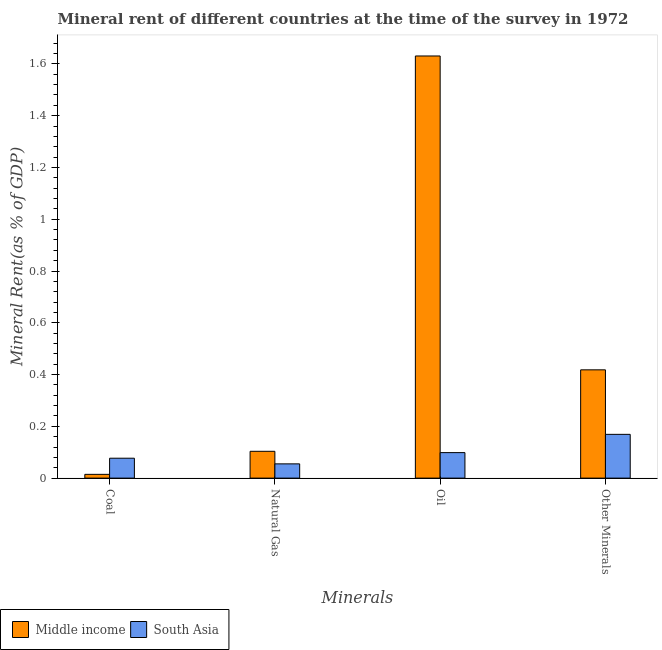How many groups of bars are there?
Your answer should be compact. 4. Are the number of bars on each tick of the X-axis equal?
Your answer should be very brief. Yes. What is the label of the 2nd group of bars from the left?
Offer a terse response. Natural Gas. What is the  rent of other minerals in Middle income?
Provide a succinct answer. 0.42. Across all countries, what is the maximum natural gas rent?
Offer a very short reply. 0.1. Across all countries, what is the minimum oil rent?
Make the answer very short. 0.1. In which country was the oil rent minimum?
Offer a very short reply. South Asia. What is the total  rent of other minerals in the graph?
Your answer should be compact. 0.59. What is the difference between the coal rent in Middle income and that in South Asia?
Your answer should be very brief. -0.06. What is the difference between the oil rent in Middle income and the coal rent in South Asia?
Offer a terse response. 1.55. What is the average natural gas rent per country?
Your answer should be compact. 0.08. What is the difference between the oil rent and natural gas rent in Middle income?
Give a very brief answer. 1.53. What is the ratio of the coal rent in South Asia to that in Middle income?
Offer a terse response. 5.27. What is the difference between the highest and the second highest coal rent?
Keep it short and to the point. 0.06. What is the difference between the highest and the lowest  rent of other minerals?
Ensure brevity in your answer.  0.25. In how many countries, is the natural gas rent greater than the average natural gas rent taken over all countries?
Your response must be concise. 1. Is the sum of the oil rent in Middle income and South Asia greater than the maximum natural gas rent across all countries?
Offer a very short reply. Yes. Is it the case that in every country, the sum of the  rent of other minerals and natural gas rent is greater than the sum of coal rent and oil rent?
Your answer should be compact. Yes. What does the 2nd bar from the right in Oil represents?
Your response must be concise. Middle income. Is it the case that in every country, the sum of the coal rent and natural gas rent is greater than the oil rent?
Give a very brief answer. No. How many bars are there?
Ensure brevity in your answer.  8. Are all the bars in the graph horizontal?
Offer a very short reply. No. How many countries are there in the graph?
Provide a succinct answer. 2. What is the difference between two consecutive major ticks on the Y-axis?
Provide a succinct answer. 0.2. Are the values on the major ticks of Y-axis written in scientific E-notation?
Offer a very short reply. No. Does the graph contain any zero values?
Your response must be concise. No. Where does the legend appear in the graph?
Keep it short and to the point. Bottom left. What is the title of the graph?
Your answer should be very brief. Mineral rent of different countries at the time of the survey in 1972. What is the label or title of the X-axis?
Provide a short and direct response. Minerals. What is the label or title of the Y-axis?
Provide a succinct answer. Mineral Rent(as % of GDP). What is the Mineral Rent(as % of GDP) in Middle income in Coal?
Offer a very short reply. 0.01. What is the Mineral Rent(as % of GDP) of South Asia in Coal?
Your answer should be very brief. 0.08. What is the Mineral Rent(as % of GDP) of Middle income in Natural Gas?
Give a very brief answer. 0.1. What is the Mineral Rent(as % of GDP) in South Asia in Natural Gas?
Your answer should be very brief. 0.06. What is the Mineral Rent(as % of GDP) of Middle income in Oil?
Your response must be concise. 1.63. What is the Mineral Rent(as % of GDP) in South Asia in Oil?
Ensure brevity in your answer.  0.1. What is the Mineral Rent(as % of GDP) in Middle income in Other Minerals?
Give a very brief answer. 0.42. What is the Mineral Rent(as % of GDP) in South Asia in Other Minerals?
Offer a very short reply. 0.17. Across all Minerals, what is the maximum Mineral Rent(as % of GDP) in Middle income?
Your answer should be very brief. 1.63. Across all Minerals, what is the maximum Mineral Rent(as % of GDP) of South Asia?
Offer a very short reply. 0.17. Across all Minerals, what is the minimum Mineral Rent(as % of GDP) of Middle income?
Give a very brief answer. 0.01. Across all Minerals, what is the minimum Mineral Rent(as % of GDP) of South Asia?
Keep it short and to the point. 0.06. What is the total Mineral Rent(as % of GDP) in Middle income in the graph?
Keep it short and to the point. 2.17. What is the total Mineral Rent(as % of GDP) in South Asia in the graph?
Your answer should be compact. 0.4. What is the difference between the Mineral Rent(as % of GDP) of Middle income in Coal and that in Natural Gas?
Keep it short and to the point. -0.09. What is the difference between the Mineral Rent(as % of GDP) in South Asia in Coal and that in Natural Gas?
Your answer should be compact. 0.02. What is the difference between the Mineral Rent(as % of GDP) in Middle income in Coal and that in Oil?
Provide a succinct answer. -1.62. What is the difference between the Mineral Rent(as % of GDP) in South Asia in Coal and that in Oil?
Provide a succinct answer. -0.02. What is the difference between the Mineral Rent(as % of GDP) of Middle income in Coal and that in Other Minerals?
Ensure brevity in your answer.  -0.4. What is the difference between the Mineral Rent(as % of GDP) of South Asia in Coal and that in Other Minerals?
Offer a terse response. -0.09. What is the difference between the Mineral Rent(as % of GDP) in Middle income in Natural Gas and that in Oil?
Provide a succinct answer. -1.53. What is the difference between the Mineral Rent(as % of GDP) in South Asia in Natural Gas and that in Oil?
Your response must be concise. -0.04. What is the difference between the Mineral Rent(as % of GDP) of Middle income in Natural Gas and that in Other Minerals?
Offer a terse response. -0.31. What is the difference between the Mineral Rent(as % of GDP) of South Asia in Natural Gas and that in Other Minerals?
Offer a very short reply. -0.11. What is the difference between the Mineral Rent(as % of GDP) in Middle income in Oil and that in Other Minerals?
Offer a very short reply. 1.21. What is the difference between the Mineral Rent(as % of GDP) of South Asia in Oil and that in Other Minerals?
Provide a succinct answer. -0.07. What is the difference between the Mineral Rent(as % of GDP) of Middle income in Coal and the Mineral Rent(as % of GDP) of South Asia in Natural Gas?
Ensure brevity in your answer.  -0.04. What is the difference between the Mineral Rent(as % of GDP) in Middle income in Coal and the Mineral Rent(as % of GDP) in South Asia in Oil?
Your response must be concise. -0.08. What is the difference between the Mineral Rent(as % of GDP) of Middle income in Coal and the Mineral Rent(as % of GDP) of South Asia in Other Minerals?
Give a very brief answer. -0.15. What is the difference between the Mineral Rent(as % of GDP) in Middle income in Natural Gas and the Mineral Rent(as % of GDP) in South Asia in Oil?
Ensure brevity in your answer.  0.01. What is the difference between the Mineral Rent(as % of GDP) of Middle income in Natural Gas and the Mineral Rent(as % of GDP) of South Asia in Other Minerals?
Make the answer very short. -0.07. What is the difference between the Mineral Rent(as % of GDP) of Middle income in Oil and the Mineral Rent(as % of GDP) of South Asia in Other Minerals?
Make the answer very short. 1.46. What is the average Mineral Rent(as % of GDP) of Middle income per Minerals?
Keep it short and to the point. 0.54. What is the average Mineral Rent(as % of GDP) in South Asia per Minerals?
Give a very brief answer. 0.1. What is the difference between the Mineral Rent(as % of GDP) in Middle income and Mineral Rent(as % of GDP) in South Asia in Coal?
Give a very brief answer. -0.06. What is the difference between the Mineral Rent(as % of GDP) of Middle income and Mineral Rent(as % of GDP) of South Asia in Natural Gas?
Give a very brief answer. 0.05. What is the difference between the Mineral Rent(as % of GDP) of Middle income and Mineral Rent(as % of GDP) of South Asia in Oil?
Make the answer very short. 1.53. What is the difference between the Mineral Rent(as % of GDP) of Middle income and Mineral Rent(as % of GDP) of South Asia in Other Minerals?
Ensure brevity in your answer.  0.25. What is the ratio of the Mineral Rent(as % of GDP) of Middle income in Coal to that in Natural Gas?
Provide a succinct answer. 0.14. What is the ratio of the Mineral Rent(as % of GDP) of South Asia in Coal to that in Natural Gas?
Provide a succinct answer. 1.4. What is the ratio of the Mineral Rent(as % of GDP) of Middle income in Coal to that in Oil?
Give a very brief answer. 0.01. What is the ratio of the Mineral Rent(as % of GDP) of South Asia in Coal to that in Oil?
Provide a succinct answer. 0.78. What is the ratio of the Mineral Rent(as % of GDP) in Middle income in Coal to that in Other Minerals?
Provide a short and direct response. 0.03. What is the ratio of the Mineral Rent(as % of GDP) in South Asia in Coal to that in Other Minerals?
Your answer should be compact. 0.45. What is the ratio of the Mineral Rent(as % of GDP) of Middle income in Natural Gas to that in Oil?
Ensure brevity in your answer.  0.06. What is the ratio of the Mineral Rent(as % of GDP) of South Asia in Natural Gas to that in Oil?
Your answer should be very brief. 0.56. What is the ratio of the Mineral Rent(as % of GDP) in Middle income in Natural Gas to that in Other Minerals?
Offer a very short reply. 0.25. What is the ratio of the Mineral Rent(as % of GDP) of South Asia in Natural Gas to that in Other Minerals?
Give a very brief answer. 0.33. What is the ratio of the Mineral Rent(as % of GDP) of Middle income in Oil to that in Other Minerals?
Keep it short and to the point. 3.9. What is the ratio of the Mineral Rent(as % of GDP) of South Asia in Oil to that in Other Minerals?
Provide a short and direct response. 0.58. What is the difference between the highest and the second highest Mineral Rent(as % of GDP) in Middle income?
Provide a succinct answer. 1.21. What is the difference between the highest and the second highest Mineral Rent(as % of GDP) of South Asia?
Your response must be concise. 0.07. What is the difference between the highest and the lowest Mineral Rent(as % of GDP) in Middle income?
Offer a very short reply. 1.62. What is the difference between the highest and the lowest Mineral Rent(as % of GDP) of South Asia?
Provide a succinct answer. 0.11. 